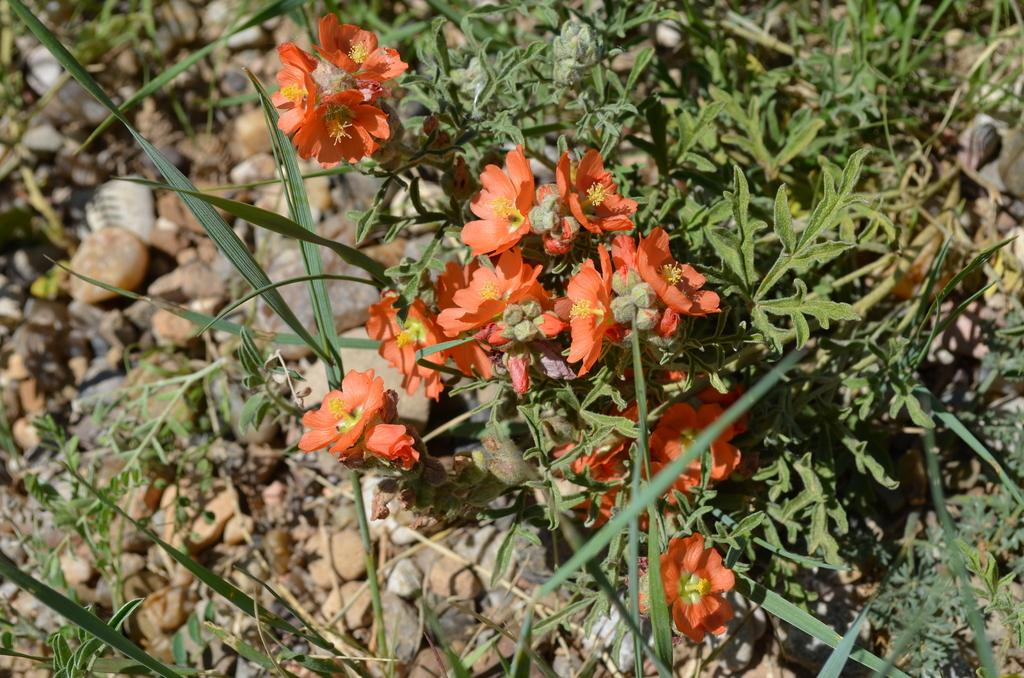What type of living organisms can be seen in the image? Plants can be seen in the image. What stage of growth are some of the plants in? There are buds in the image, which indicates that some plants are in the early stages of growth. What other objects are present in the image? There are stones in the image. What type of club can be seen in the image? There is no club present in the image; it features plants, buds, and stones. 